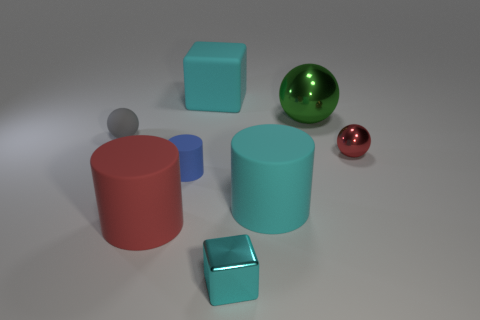The metallic block that is the same size as the red shiny ball is what color?
Your response must be concise. Cyan. Are the green object and the tiny cyan cube made of the same material?
Give a very brief answer. Yes. What number of other cubes have the same color as the shiny block?
Your response must be concise. 1. Does the matte cube have the same color as the metal block?
Offer a very short reply. Yes. There is a thing on the right side of the large shiny object; what is its material?
Offer a very short reply. Metal. What number of big things are either gray blocks or metallic cubes?
Give a very brief answer. 0. There is a cylinder that is the same color as the big block; what is it made of?
Offer a very short reply. Rubber. Are there any big red objects that have the same material as the large ball?
Your response must be concise. No. Does the cyan cube that is behind the red shiny object have the same size as the big red rubber thing?
Ensure brevity in your answer.  Yes. There is a large cylinder right of the tiny rubber cylinder to the left of the tiny red metal object; are there any balls that are right of it?
Your answer should be compact. Yes. 